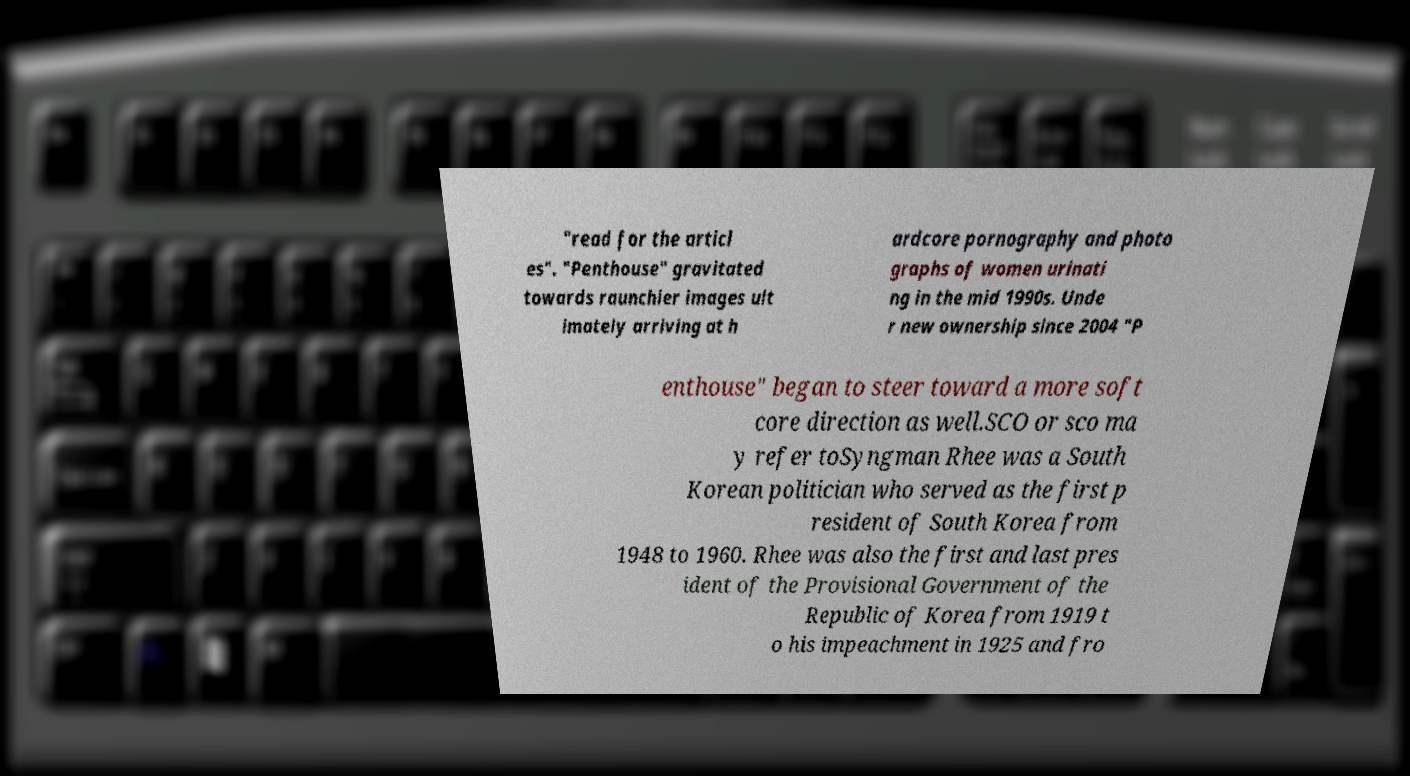Can you read and provide the text displayed in the image?This photo seems to have some interesting text. Can you extract and type it out for me? "read for the articl es". "Penthouse" gravitated towards raunchier images ult imately arriving at h ardcore pornography and photo graphs of women urinati ng in the mid 1990s. Unde r new ownership since 2004 "P enthouse" began to steer toward a more soft core direction as well.SCO or sco ma y refer toSyngman Rhee was a South Korean politician who served as the first p resident of South Korea from 1948 to 1960. Rhee was also the first and last pres ident of the Provisional Government of the Republic of Korea from 1919 t o his impeachment in 1925 and fro 